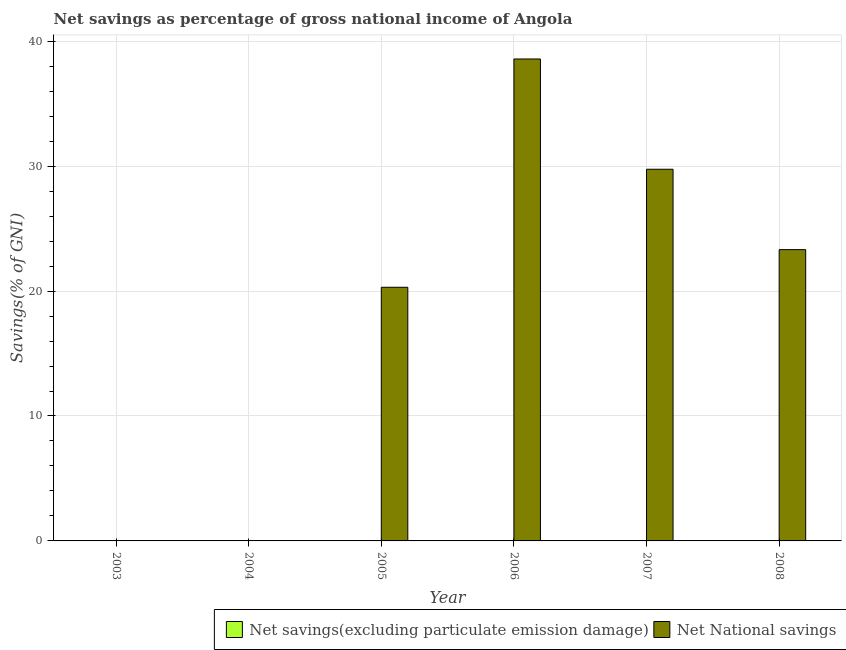How many different coloured bars are there?
Keep it short and to the point. 1. Are the number of bars per tick equal to the number of legend labels?
Provide a short and direct response. No. How many bars are there on the 6th tick from the left?
Your answer should be very brief. 1. What is the label of the 1st group of bars from the left?
Give a very brief answer. 2003. In how many cases, is the number of bars for a given year not equal to the number of legend labels?
Your answer should be very brief. 6. What is the net savings(excluding particulate emission damage) in 2006?
Offer a very short reply. 0. What is the total net savings(excluding particulate emission damage) in the graph?
Ensure brevity in your answer.  0. What is the difference between the net national savings in 2006 and that in 2008?
Offer a very short reply. 15.26. What is the difference between the net national savings in 2008 and the net savings(excluding particulate emission damage) in 2004?
Provide a short and direct response. 23.32. What is the average net national savings per year?
Provide a short and direct response. 18.66. In the year 2006, what is the difference between the net national savings and net savings(excluding particulate emission damage)?
Offer a very short reply. 0. What is the ratio of the net national savings in 2005 to that in 2006?
Your response must be concise. 0.53. What is the difference between the highest and the second highest net national savings?
Your answer should be very brief. 8.83. What is the difference between the highest and the lowest net national savings?
Offer a very short reply. 38.58. In how many years, is the net national savings greater than the average net national savings taken over all years?
Make the answer very short. 4. How many bars are there?
Ensure brevity in your answer.  4. Are all the bars in the graph horizontal?
Offer a very short reply. No. Are the values on the major ticks of Y-axis written in scientific E-notation?
Provide a succinct answer. No. What is the title of the graph?
Offer a very short reply. Net savings as percentage of gross national income of Angola. Does "Measles" appear as one of the legend labels in the graph?
Ensure brevity in your answer.  No. What is the label or title of the X-axis?
Provide a succinct answer. Year. What is the label or title of the Y-axis?
Your answer should be compact. Savings(% of GNI). What is the Savings(% of GNI) of Net National savings in 2003?
Give a very brief answer. 0. What is the Savings(% of GNI) of Net National savings in 2004?
Keep it short and to the point. 0. What is the Savings(% of GNI) of Net National savings in 2005?
Your answer should be compact. 20.3. What is the Savings(% of GNI) in Net National savings in 2006?
Your answer should be compact. 38.58. What is the Savings(% of GNI) in Net savings(excluding particulate emission damage) in 2007?
Keep it short and to the point. 0. What is the Savings(% of GNI) in Net National savings in 2007?
Offer a terse response. 29.75. What is the Savings(% of GNI) in Net savings(excluding particulate emission damage) in 2008?
Keep it short and to the point. 0. What is the Savings(% of GNI) in Net National savings in 2008?
Keep it short and to the point. 23.32. Across all years, what is the maximum Savings(% of GNI) in Net National savings?
Make the answer very short. 38.58. Across all years, what is the minimum Savings(% of GNI) in Net National savings?
Keep it short and to the point. 0. What is the total Savings(% of GNI) of Net savings(excluding particulate emission damage) in the graph?
Provide a short and direct response. 0. What is the total Savings(% of GNI) in Net National savings in the graph?
Your answer should be compact. 111.95. What is the difference between the Savings(% of GNI) in Net National savings in 2005 and that in 2006?
Provide a short and direct response. -18.27. What is the difference between the Savings(% of GNI) of Net National savings in 2005 and that in 2007?
Your answer should be compact. -9.45. What is the difference between the Savings(% of GNI) of Net National savings in 2005 and that in 2008?
Ensure brevity in your answer.  -3.01. What is the difference between the Savings(% of GNI) of Net National savings in 2006 and that in 2007?
Make the answer very short. 8.83. What is the difference between the Savings(% of GNI) of Net National savings in 2006 and that in 2008?
Your response must be concise. 15.26. What is the difference between the Savings(% of GNI) of Net National savings in 2007 and that in 2008?
Your answer should be very brief. 6.44. What is the average Savings(% of GNI) of Net savings(excluding particulate emission damage) per year?
Offer a terse response. 0. What is the average Savings(% of GNI) of Net National savings per year?
Provide a succinct answer. 18.66. What is the ratio of the Savings(% of GNI) in Net National savings in 2005 to that in 2006?
Make the answer very short. 0.53. What is the ratio of the Savings(% of GNI) in Net National savings in 2005 to that in 2007?
Your answer should be very brief. 0.68. What is the ratio of the Savings(% of GNI) of Net National savings in 2005 to that in 2008?
Provide a short and direct response. 0.87. What is the ratio of the Savings(% of GNI) in Net National savings in 2006 to that in 2007?
Make the answer very short. 1.3. What is the ratio of the Savings(% of GNI) of Net National savings in 2006 to that in 2008?
Ensure brevity in your answer.  1.65. What is the ratio of the Savings(% of GNI) of Net National savings in 2007 to that in 2008?
Your answer should be very brief. 1.28. What is the difference between the highest and the second highest Savings(% of GNI) in Net National savings?
Provide a short and direct response. 8.83. What is the difference between the highest and the lowest Savings(% of GNI) of Net National savings?
Ensure brevity in your answer.  38.58. 